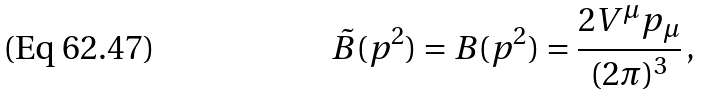<formula> <loc_0><loc_0><loc_500><loc_500>\tilde { B } ( p ^ { 2 } ) = B ( p ^ { 2 } ) = \frac { 2 V ^ { \mu } p _ { \mu } } { ( 2 \pi ) ^ { 3 } } \, ,</formula> 